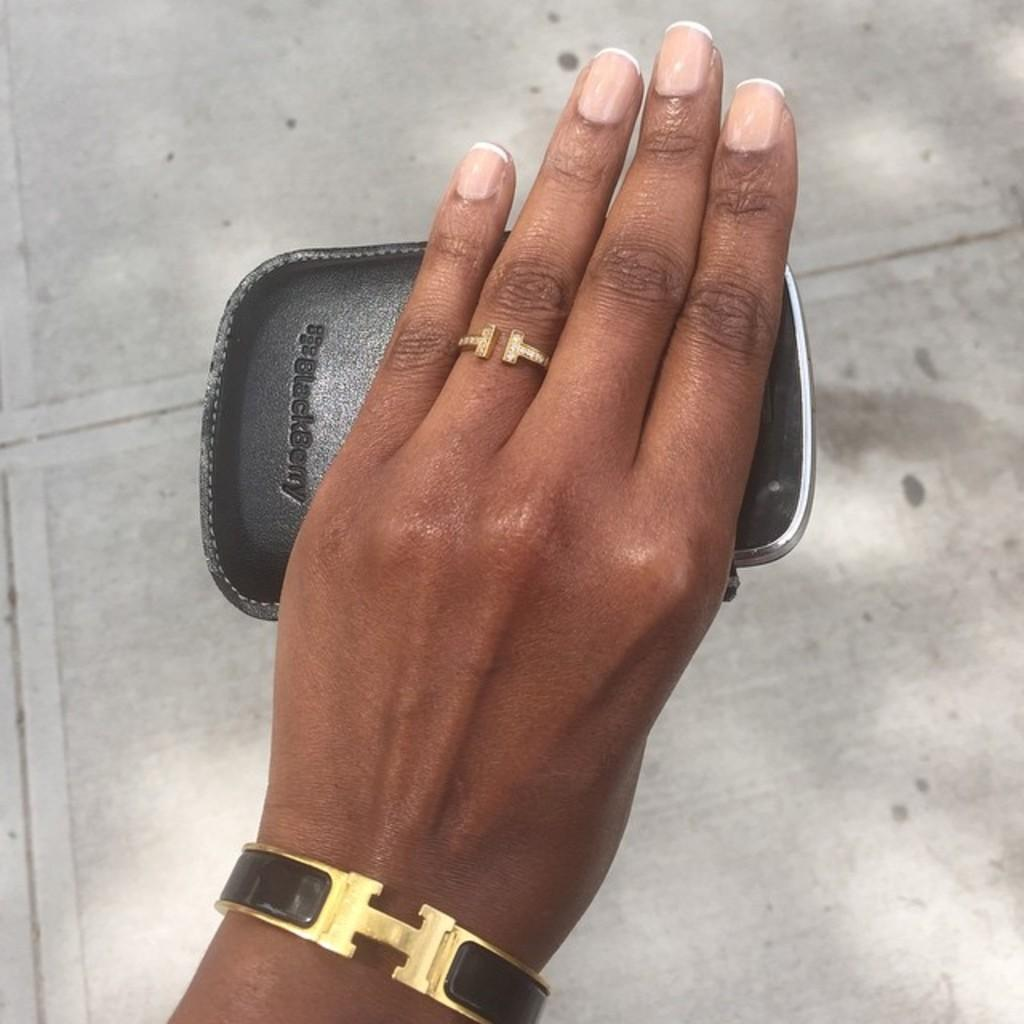<image>
Present a compact description of the photo's key features. a woman wearing Tiffany jewelry has a Blackberry in her hand 